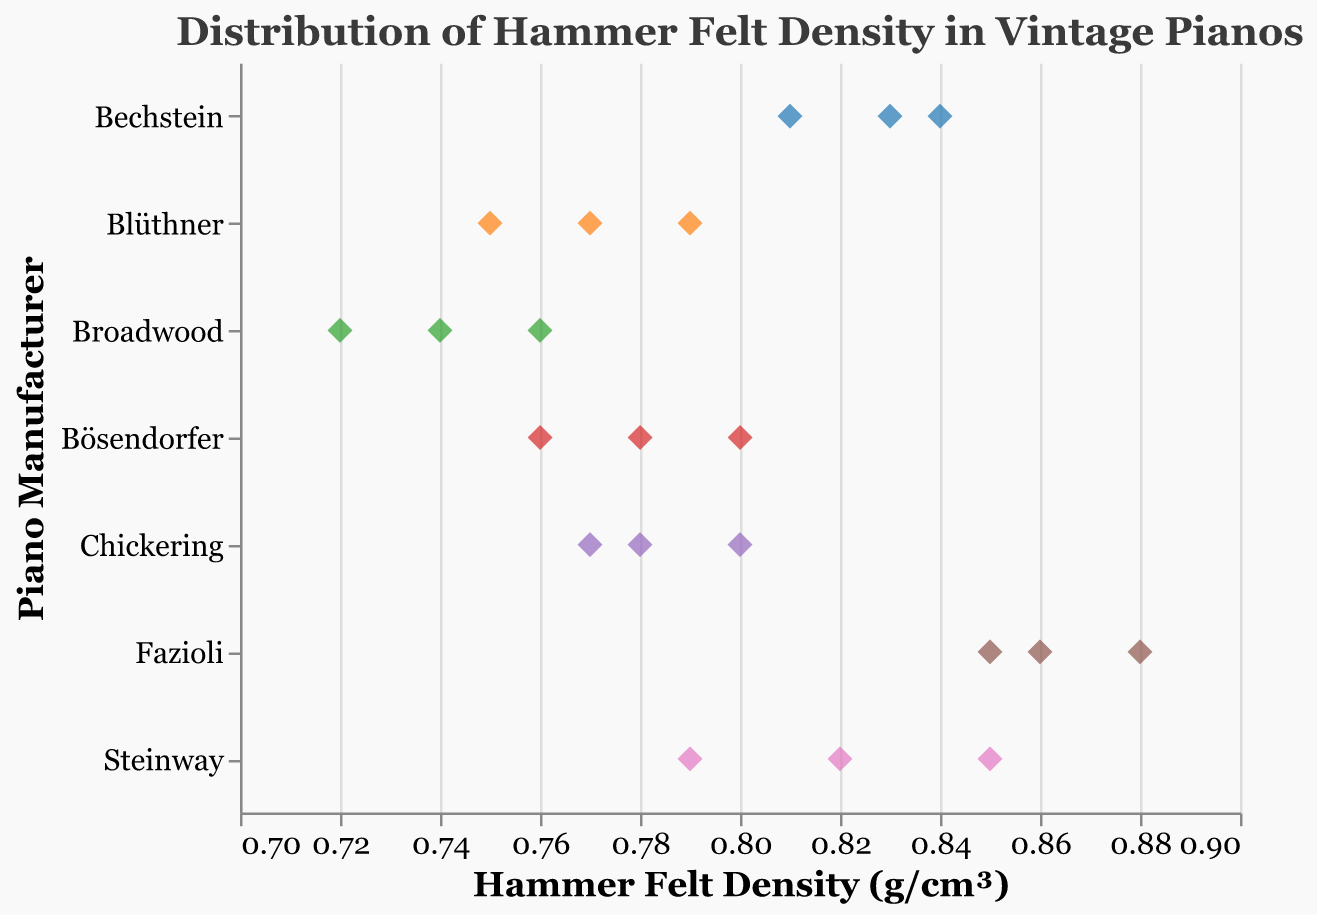How many manufacturers are there in the plot? Each point in the plot represents a vintage piano with a specific hammer felt density from a specific manufacturer. By counting the unique manufacturers displayed on the y-axis, we can determine the number of manufacturers.
Answer: 7 Which manufacturer has the highest hammer felt density? To find the manufacturer with the highest density, look for the point furthest to the right on the x-axis. Fazioli has the highest density with a value of 0.88 g/cm³.
Answer: Fazioli What is the range of hammer felt densities for Steinway pianos? The range can be found by identifying the minimum and maximum hammer felt density values for Steinway pianos. The minimum is 0.79 g/cm³ and the maximum is 0.85 g/cm³.
Answer: 0.79 - 0.85 g/cm³ Which manufacturers have hammer felt densities in the range of 0.75 to 0.80 g/cm³? By looking at the x-axis, identify the points that fall within the 0.75 to 0.80 g/cm³ range and observe their associated manufacturers. Chickering, Blüthner, Bösendorfer, and Broadwood have densities in this range.
Answer: Chickering, Blüthner, Bösendorfer, Broadwood Which manufacturer has the most narrow distribution of hammer felt densities? To determine the most narrow distribution, look at the spread of points for each manufacturer. Bechstein has the narrowest distribution since its points are tightly clustered around 0.83-0.84 g/cm³.
Answer: Bechstein What is the average hammer felt density for Blüthner pianos? Calculate the average by summing up the hammer felt densities for Blüthner (0.77 + 0.79 + 0.75) and then dividing by the number of points (3). The sum is 2.31, so the average is 2.31/3 ≈ 0.77 g/cm³.
Answer: 0.77 g/cm³ How does the hammer felt density of Broadwood compare to Fazioli? Compare the two manufacturers by looking at their respective densities on the x-axis. Broadwood's densities range from 0.72 to 0.76 g/cm³, while Fazioli's densities range from 0.85 to 0.88 g/cm³. Fazioli has consistently higher densities than Broadwood.
Answer: Fazioli has higher densities Which point represents the highest density value and what is its tooltip data? The highest density value is the furthest right point on the x-axis with a density of 0.88 g/cm³. The tooltip data will show "Manufacturer: Fazioli" and "Hammer Felt Density (g/cm³): 0.88."
Answer: Manufacturer: Fazioli, Hammer Felt Density (g/cm³): 0.88 